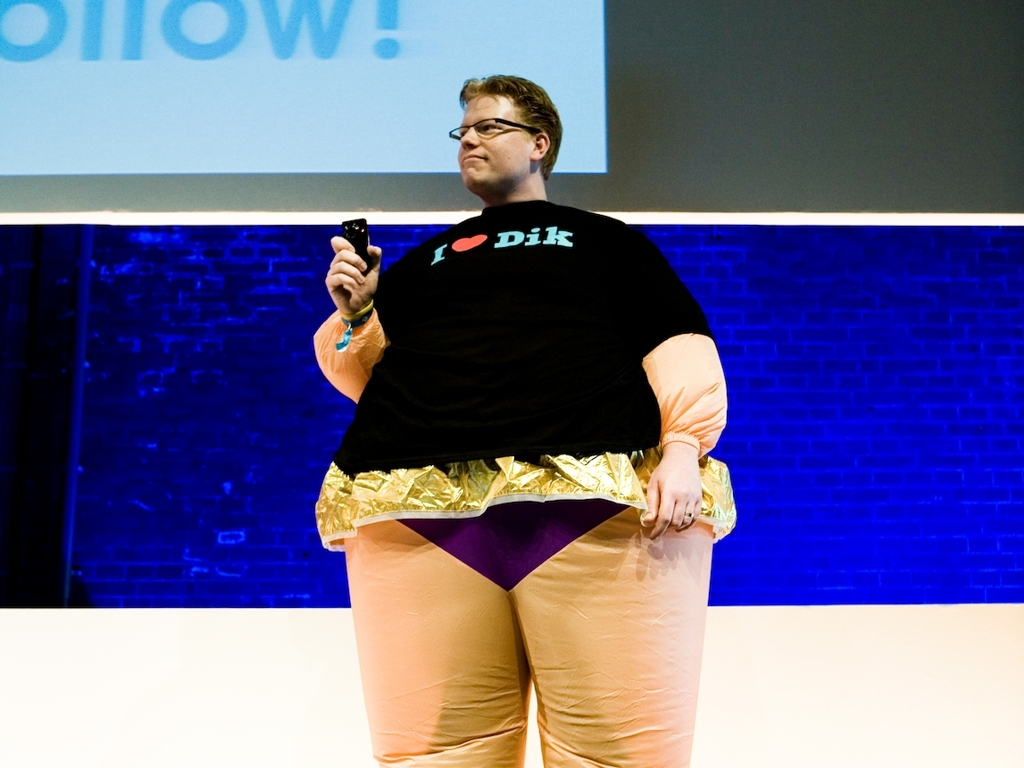What is the likely context or event taking place based on the image? Given the person's distinct attire and the presence of a stage with a backdrop that includes a large screen displaying text, it suggests that the person might be part of a performance or presentation, possibly in a casual or informal setting aimed at entertaining an audience. 